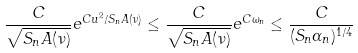<formula> <loc_0><loc_0><loc_500><loc_500>\frac { C } { \sqrt { S _ { n } A ( \nu ) } } e ^ { C u ^ { 2 } / S _ { n } A ( \nu ) } \leq \frac { C } { \sqrt { S _ { n } A ( \nu ) } } e ^ { C \omega _ { n } } \leq \frac { C } { ( S _ { n } \alpha _ { n } ) ^ { 1 / 4 } }</formula> 